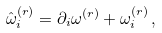Convert formula to latex. <formula><loc_0><loc_0><loc_500><loc_500>\hat { \omega } _ { i } ^ { ( r ) } = \partial _ { i } \omega ^ { ( r ) } + \omega _ { i } ^ { ( r ) } \, ,</formula> 